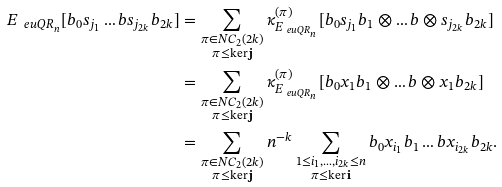<formula> <loc_0><loc_0><loc_500><loc_500>E _ { \ e u { Q R } _ { n } } [ b _ { 0 } s _ { j _ { 1 } } \dots b s _ { j _ { 2 k } } b _ { 2 k } ] & = \sum _ { \substack { \pi \in N C _ { 2 } ( 2 k ) \\ \pi \leq \ker \mathbf j } } \kappa _ { E _ { \ e u { Q R } _ { n } } } ^ { ( \pi ) } [ b _ { 0 } s _ { j _ { 1 } } b _ { 1 } \otimes \dots b \otimes s _ { j _ { 2 k } } b _ { 2 k } ] \\ & = \sum _ { \substack { \pi \in N C _ { 2 } ( 2 k ) \\ \pi \leq \ker \mathbf j } } \kappa _ { E _ { \ e u { Q R } _ { n } } } ^ { ( \pi ) } [ b _ { 0 } x _ { 1 } b _ { 1 } \otimes \dots b \otimes x _ { 1 } b _ { 2 k } ] \\ & = \sum _ { \substack { \pi \in N C _ { 2 } ( 2 k ) \\ \pi \leq \ker \mathbf j } } n ^ { - k } \sum _ { \substack { 1 \leq i _ { 1 } , \dots , i _ { 2 k } \leq n \\ \pi \leq \ker \mathbf i } } b _ { 0 } x _ { i _ { 1 } } b _ { 1 } \dots b x _ { i _ { 2 k } } b _ { 2 k } .</formula> 